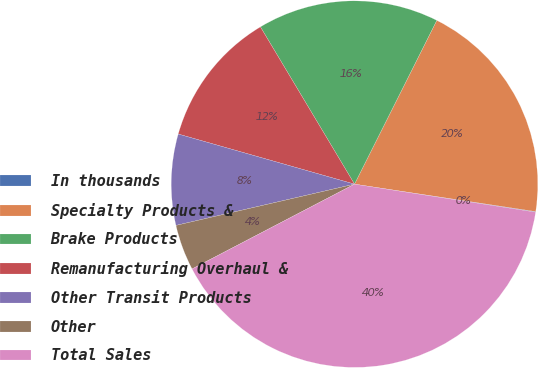Convert chart. <chart><loc_0><loc_0><loc_500><loc_500><pie_chart><fcel>In thousands<fcel>Specialty Products &<fcel>Brake Products<fcel>Remanufacturing Overhaul &<fcel>Other Transit Products<fcel>Other<fcel>Total Sales<nl><fcel>0.05%<fcel>19.98%<fcel>15.99%<fcel>12.01%<fcel>8.02%<fcel>4.04%<fcel>39.9%<nl></chart> 